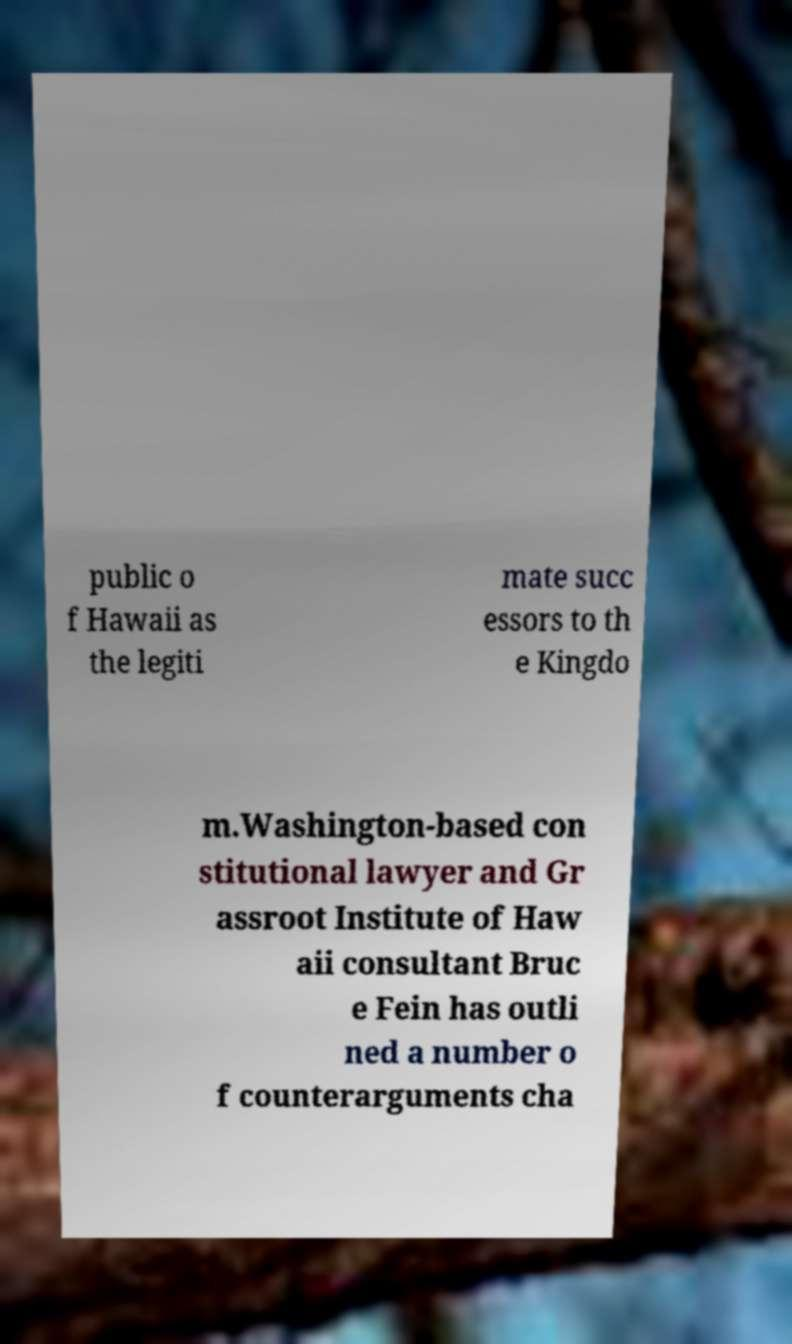What messages or text are displayed in this image? I need them in a readable, typed format. public o f Hawaii as the legiti mate succ essors to th e Kingdo m.Washington-based con stitutional lawyer and Gr assroot Institute of Haw aii consultant Bruc e Fein has outli ned a number o f counterarguments cha 